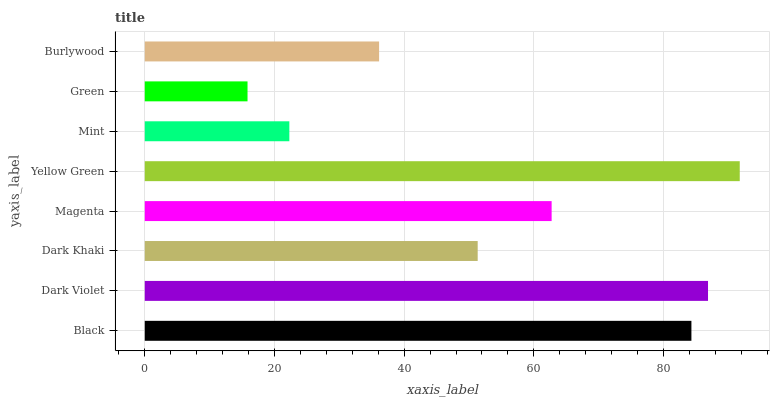Is Green the minimum?
Answer yes or no. Yes. Is Yellow Green the maximum?
Answer yes or no. Yes. Is Dark Violet the minimum?
Answer yes or no. No. Is Dark Violet the maximum?
Answer yes or no. No. Is Dark Violet greater than Black?
Answer yes or no. Yes. Is Black less than Dark Violet?
Answer yes or no. Yes. Is Black greater than Dark Violet?
Answer yes or no. No. Is Dark Violet less than Black?
Answer yes or no. No. Is Magenta the high median?
Answer yes or no. Yes. Is Dark Khaki the low median?
Answer yes or no. Yes. Is Black the high median?
Answer yes or no. No. Is Green the low median?
Answer yes or no. No. 